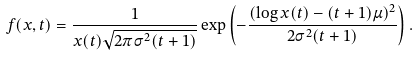<formula> <loc_0><loc_0><loc_500><loc_500>f ( x , t ) = \frac { 1 } { x ( t ) \sqrt { 2 \pi \sigma ^ { 2 } ( t + 1 ) } } \exp \left ( - \frac { ( \log x ( t ) - ( t + 1 ) \mu ) ^ { 2 } } { 2 \sigma ^ { 2 } ( t + 1 ) } \right ) .</formula> 